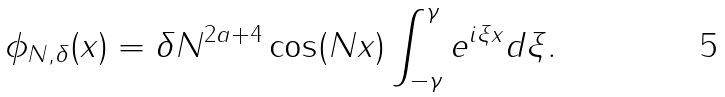Convert formula to latex. <formula><loc_0><loc_0><loc_500><loc_500>\phi _ { N , \delta } ( x ) = \delta N ^ { 2 a + 4 } \cos ( N x ) \int _ { - \gamma } ^ { \gamma } e ^ { i \xi x } d \xi .</formula> 